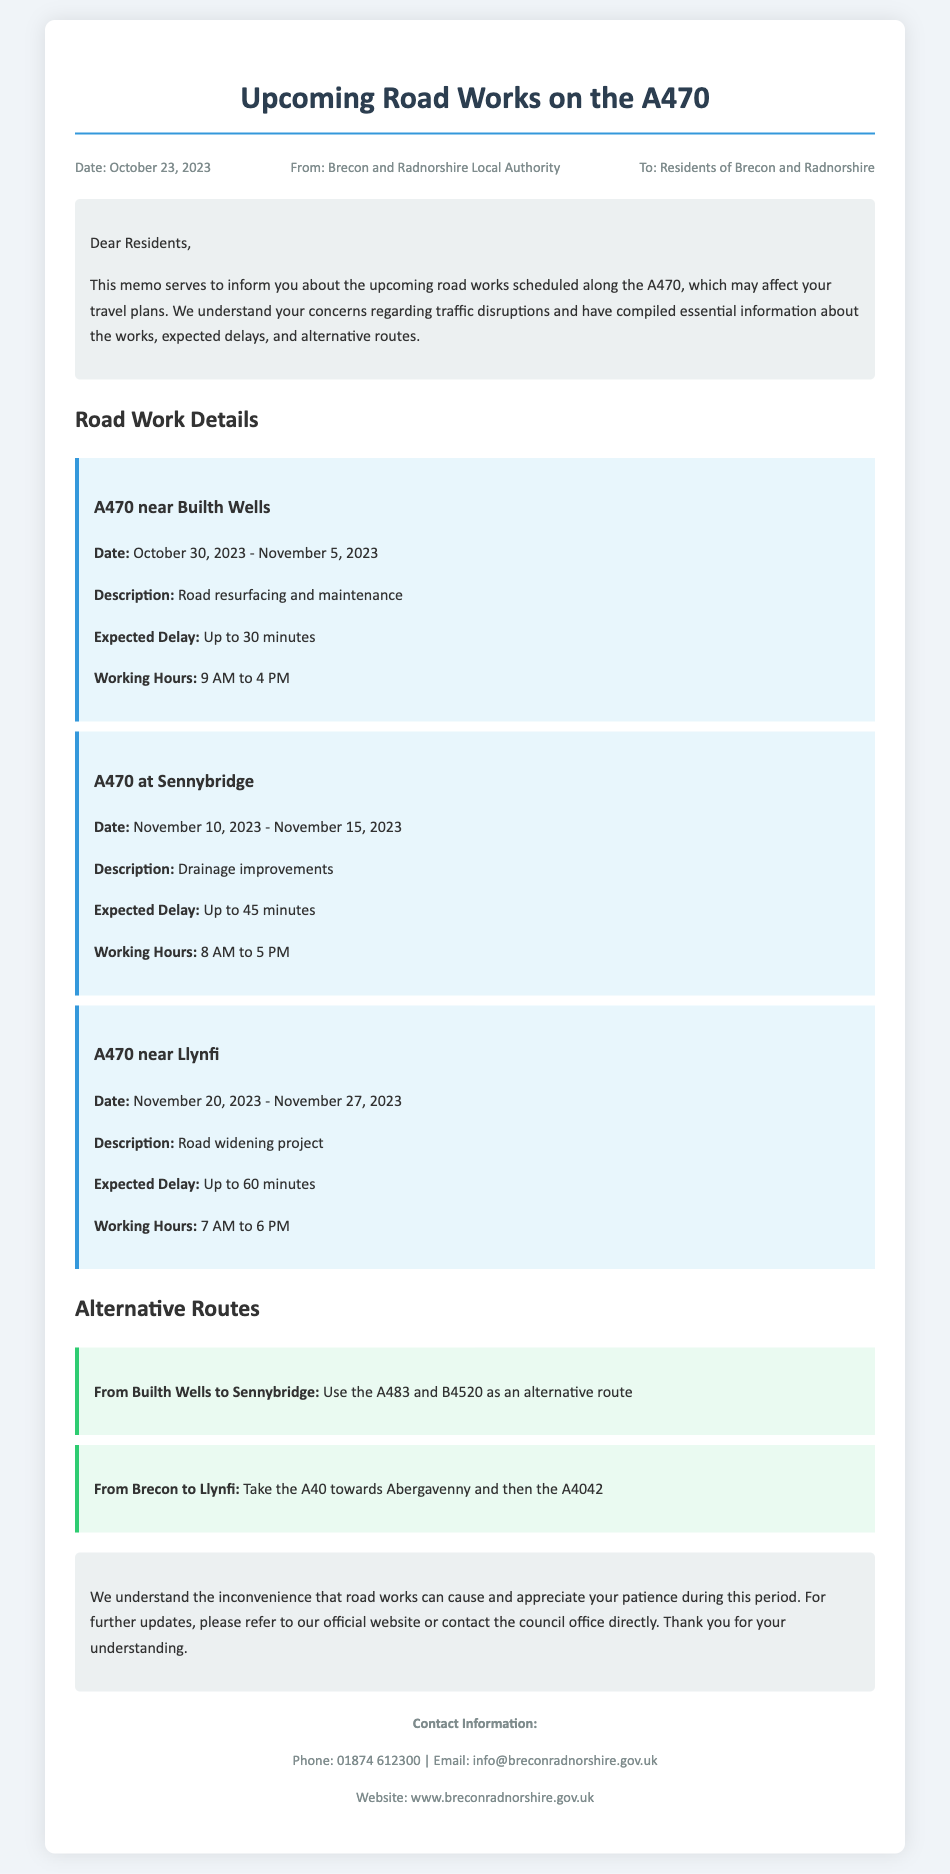What are the working hours for road works at Sennybridge? The working hours for Sennybridge are stated in the document as 8 AM to 5 PM.
Answer: 8 AM to 5 PM What is the expected delay for the road works near Llynfi? The document specifies that the expected delay for works near Llynfi is up to 60 minutes.
Answer: Up to 60 minutes When will the road works near Builth Wells start? According to the document, the road works near Builth Wells will start on October 30, 2023.
Answer: October 30, 2023 What alternative route is suggested from Brecon to Llynfi? The document provides the alternative route from Brecon to Llynfi as A40 towards Abergavenny and then the A4042.
Answer: A40 towards Abergavenny and then the A4042 What type of work is being done at Sennybridge? The document describes the work at Sennybridge as drainage improvements.
Answer: Drainage improvements How long will the road works near Builth Wells last? The document states that the road works near Builth Wells will last from October 30 to November 5, 2023.
Answer: October 30 to November 5, 2023 What is the contact phone number provided in the memo? The document includes a contact phone number of 01874 612300 for further inquiries.
Answer: 01874 612300 What is the date of the memo? The memo specifies the date as October 23, 2023.
Answer: October 23, 2023 How many road work projects are mentioned in the memo? The document mentions three road work projects along the A470.
Answer: Three 